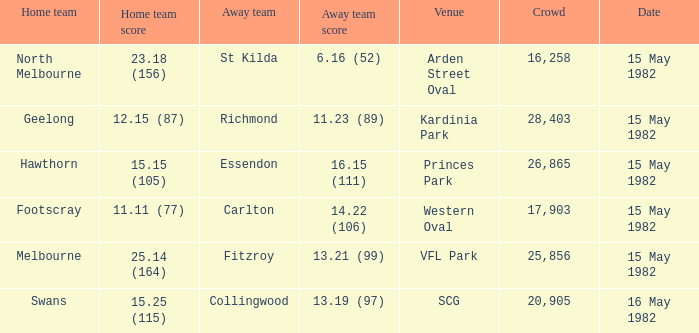Which home team played against the away team with a score of 13.19 (97)? Swans. 